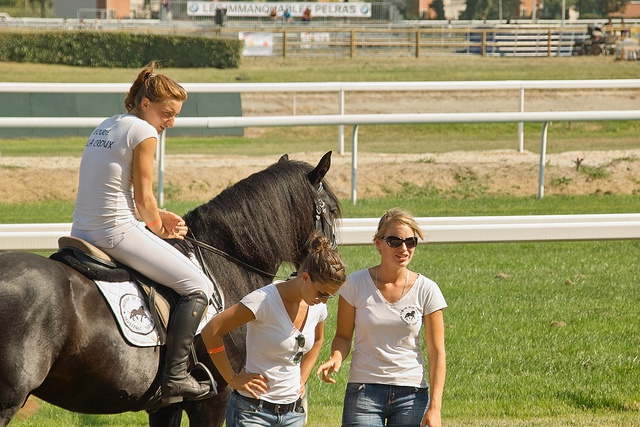Describe the objects in this image and their specific colors. I can see horse in darkgreen, black, and gray tones, people in darkgreen, gray, lightgray, and black tones, people in darkgreen, darkgray, lightgray, gray, and black tones, people in darkgreen, maroon, darkgray, lightgray, and black tones, and people in darkgreen, gray, tan, and black tones in this image. 